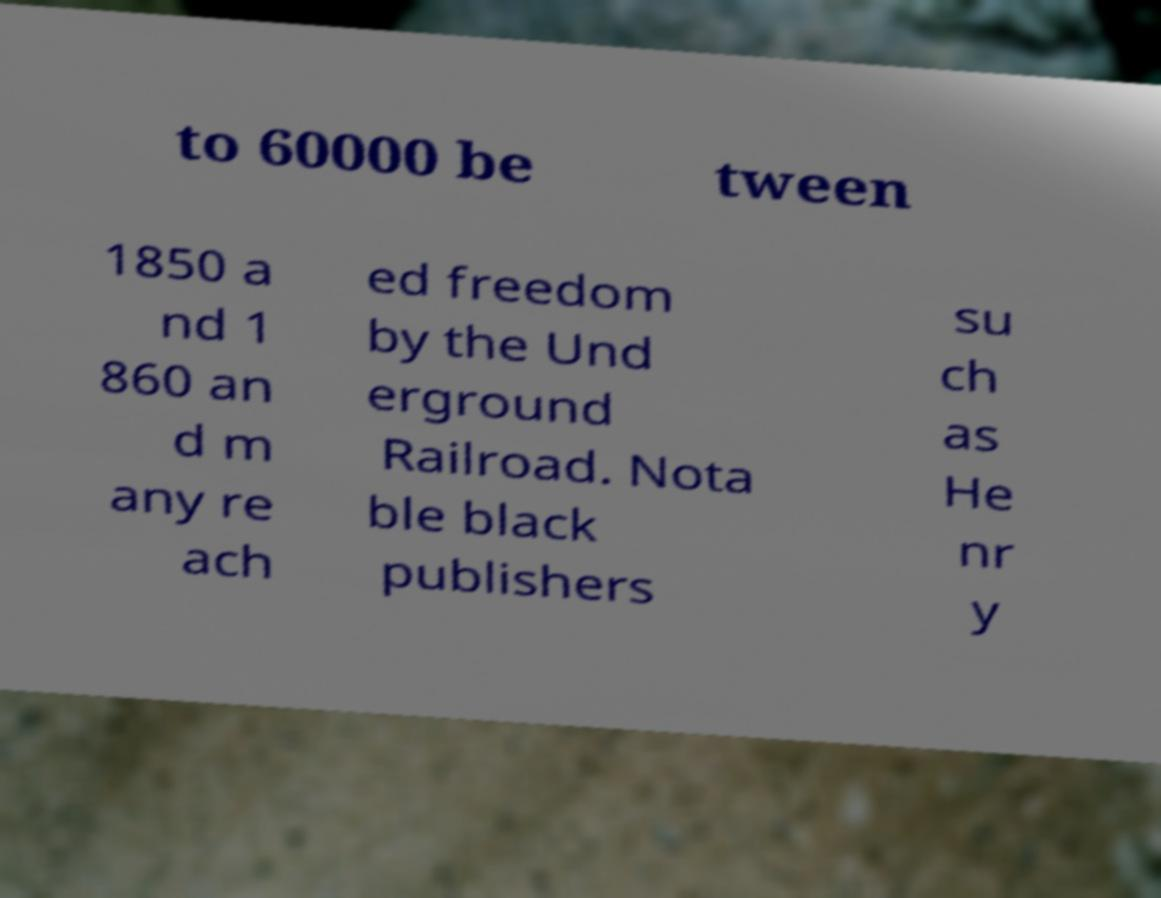Can you accurately transcribe the text from the provided image for me? to 60000 be tween 1850 a nd 1 860 an d m any re ach ed freedom by the Und erground Railroad. Nota ble black publishers su ch as He nr y 